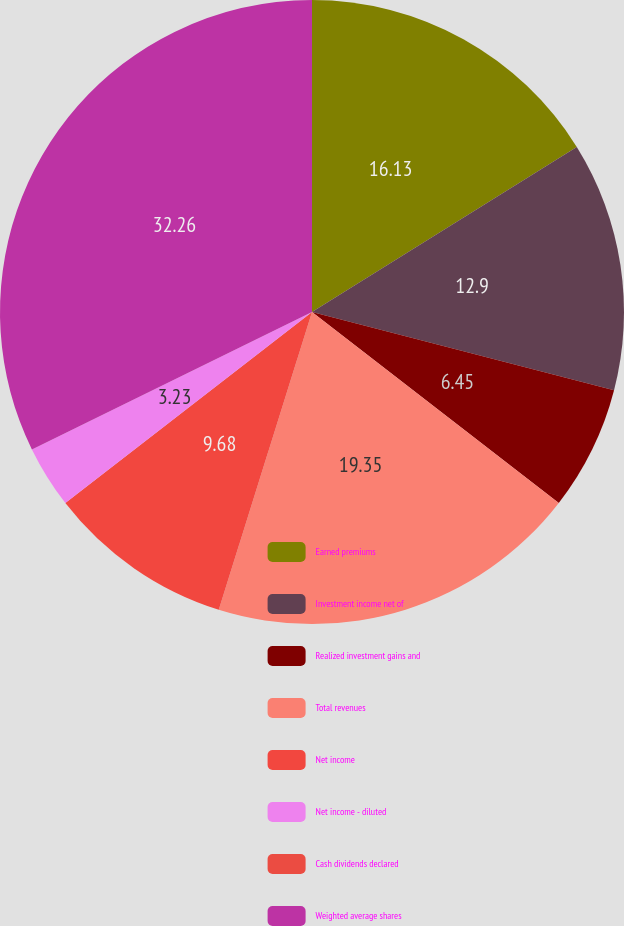Convert chart. <chart><loc_0><loc_0><loc_500><loc_500><pie_chart><fcel>Earned premiums<fcel>Investment income net of<fcel>Realized investment gains and<fcel>Total revenues<fcel>Net income<fcel>Net income - diluted<fcel>Cash dividends declared<fcel>Weighted average shares<nl><fcel>16.13%<fcel>12.9%<fcel>6.45%<fcel>19.35%<fcel>9.68%<fcel>3.23%<fcel>0.0%<fcel>32.26%<nl></chart> 